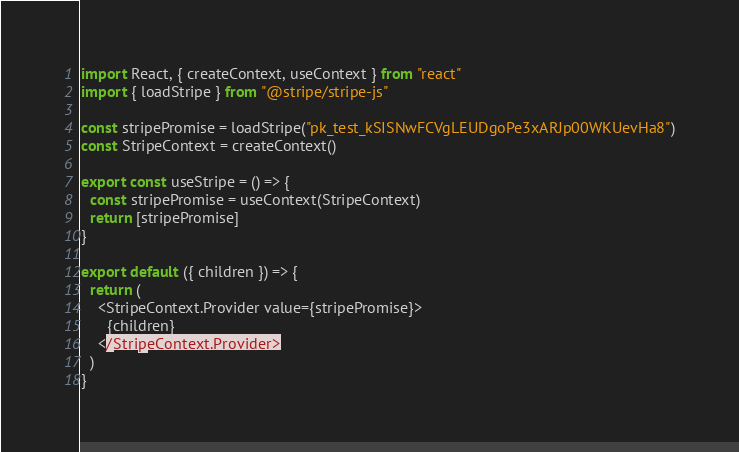Convert code to text. <code><loc_0><loc_0><loc_500><loc_500><_JavaScript_>import React, { createContext, useContext } from "react"
import { loadStripe } from "@stripe/stripe-js"

const stripePromise = loadStripe("pk_test_kSISNwFCVgLEUDgoPe3xARJp00WKUevHa8")
const StripeContext = createContext()

export const useStripe = () => {
  const stripePromise = useContext(StripeContext)
  return [stripePromise]
}

export default ({ children }) => {
  return (
    <StripeContext.Provider value={stripePromise}>
      {children}
    </StripeContext.Provider>
  )
}
</code> 